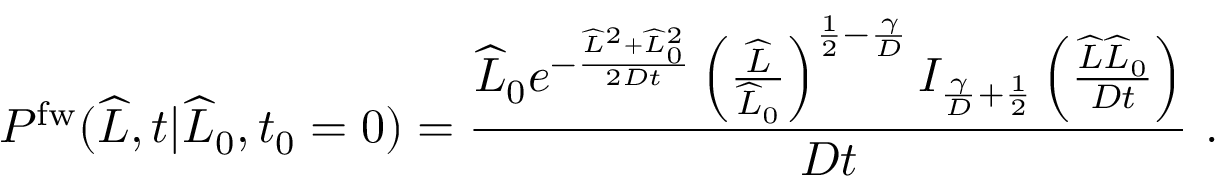<formula> <loc_0><loc_0><loc_500><loc_500>P ^ { f w } ( \widehat { L } , t | \widehat { L } _ { 0 } , t _ { 0 } = 0 ) = \frac { \widehat { L } _ { 0 } e ^ { - \frac { \widehat { L } ^ { 2 } + \widehat { L } _ { 0 } ^ { 2 } } { 2 D t } } \left ( \frac { \widehat { L } } { \widehat { L } _ { 0 } } \right ) ^ { \frac { 1 } { 2 } - \frac { \gamma } { D } } I _ { \frac { \gamma } { D } + \frac { 1 } { 2 } } \left ( \frac { \widehat { L } \widehat { L } _ { 0 } } { D t } \right ) } { D t } \ .</formula> 